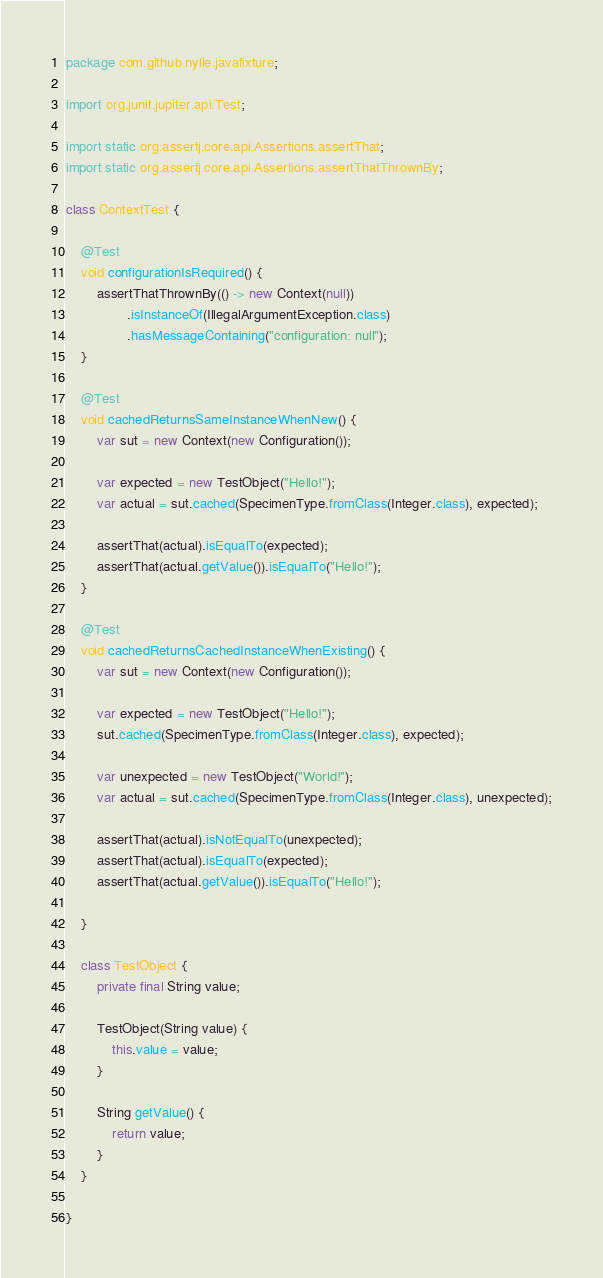<code> <loc_0><loc_0><loc_500><loc_500><_Java_>package com.github.nylle.javafixture;

import org.junit.jupiter.api.Test;

import static org.assertj.core.api.Assertions.assertThat;
import static org.assertj.core.api.Assertions.assertThatThrownBy;

class ContextTest {

    @Test
    void configurationIsRequired() {
        assertThatThrownBy(() -> new Context(null))
                .isInstanceOf(IllegalArgumentException.class)
                .hasMessageContaining("configuration: null");
    }

    @Test
    void cachedReturnsSameInstanceWhenNew() {
        var sut = new Context(new Configuration());

        var expected = new TestObject("Hello!");
        var actual = sut.cached(SpecimenType.fromClass(Integer.class), expected);

        assertThat(actual).isEqualTo(expected);
        assertThat(actual.getValue()).isEqualTo("Hello!");
    }

    @Test
    void cachedReturnsCachedInstanceWhenExisting() {
        var sut = new Context(new Configuration());

        var expected = new TestObject("Hello!");
        sut.cached(SpecimenType.fromClass(Integer.class), expected);

        var unexpected = new TestObject("World!");
        var actual = sut.cached(SpecimenType.fromClass(Integer.class), unexpected);

        assertThat(actual).isNotEqualTo(unexpected);
        assertThat(actual).isEqualTo(expected);
        assertThat(actual.getValue()).isEqualTo("Hello!");

    }

    class TestObject {
        private final String value;

        TestObject(String value) {
            this.value = value;
        }

        String getValue() {
            return value;
        }
    }

}
</code> 